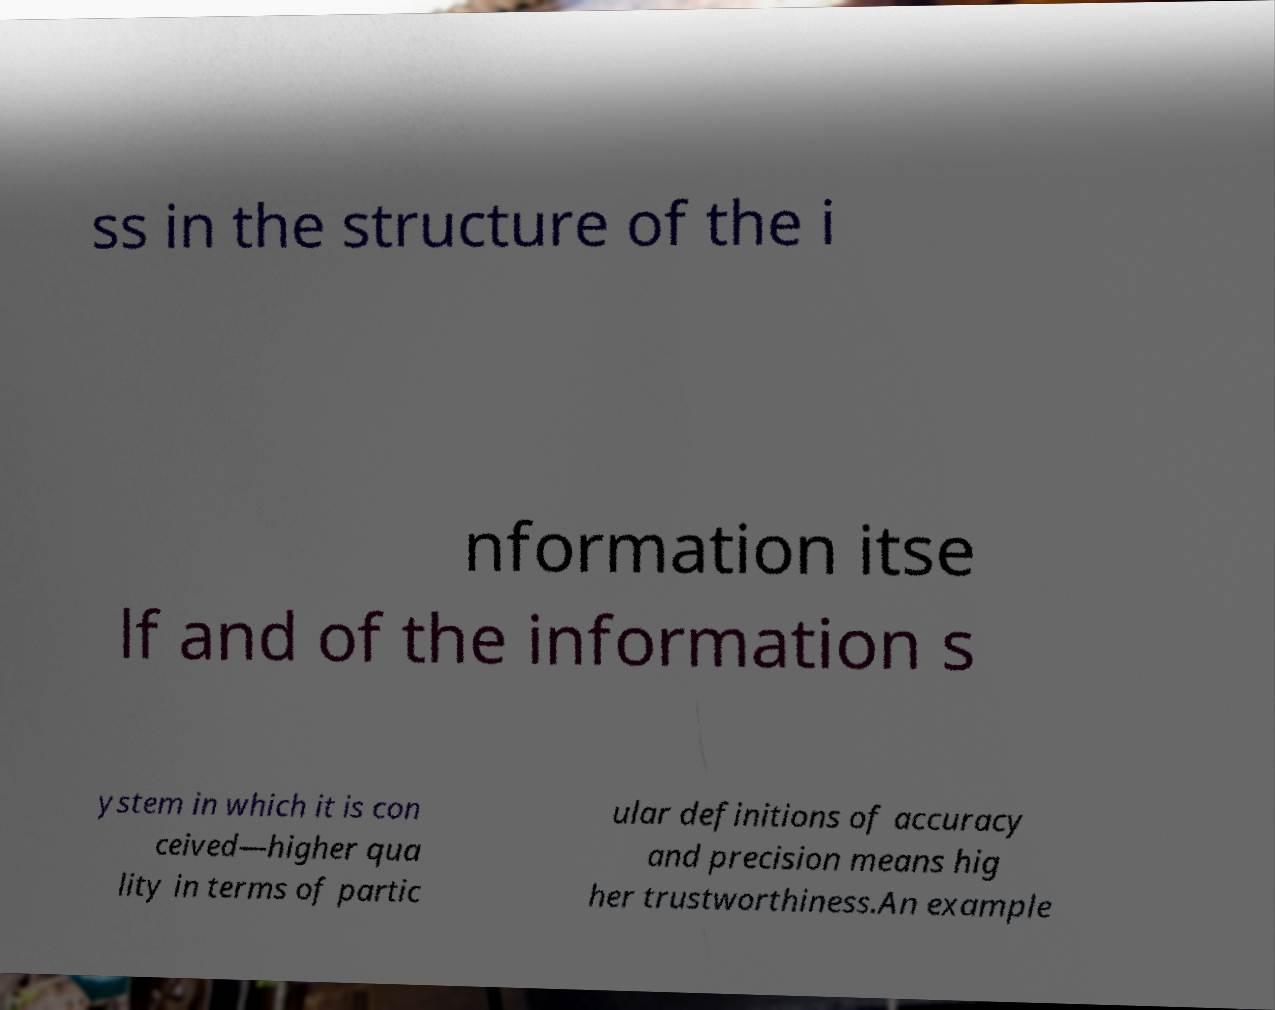I need the written content from this picture converted into text. Can you do that? ss in the structure of the i nformation itse lf and of the information s ystem in which it is con ceived—higher qua lity in terms of partic ular definitions of accuracy and precision means hig her trustworthiness.An example 